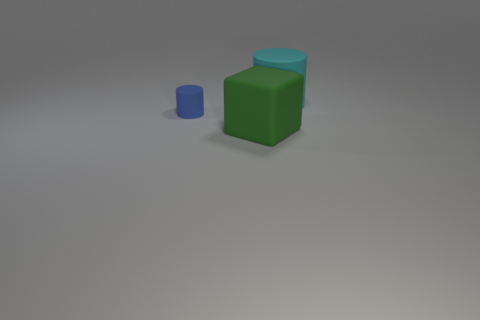Is the shape of the cyan object the same as the large green object?
Offer a very short reply. No. Are there more big rubber cylinders on the right side of the cyan rubber cylinder than cylinders that are in front of the blue thing?
Ensure brevity in your answer.  No. What color is the cube that is the same material as the blue object?
Provide a succinct answer. Green. There is a cylinder that is in front of the cyan cylinder to the right of the blue matte cylinder that is left of the block; what is its material?
Your answer should be very brief. Rubber. There is a matte cylinder that is behind the cylinder left of the matte cylinder that is behind the blue thing; what size is it?
Your response must be concise. Large. There is another cyan rubber thing that is the same shape as the tiny matte thing; what size is it?
Make the answer very short. Large. Does the large object behind the small blue rubber cylinder have the same material as the large thing that is in front of the small blue cylinder?
Give a very brief answer. Yes. What is the big object that is behind the blue matte cylinder made of?
Your answer should be very brief. Rubber. There is a thing right of the matte thing that is in front of the blue object; what color is it?
Your response must be concise. Cyan. Does the cube have the same material as the object behind the small blue thing?
Ensure brevity in your answer.  Yes. 